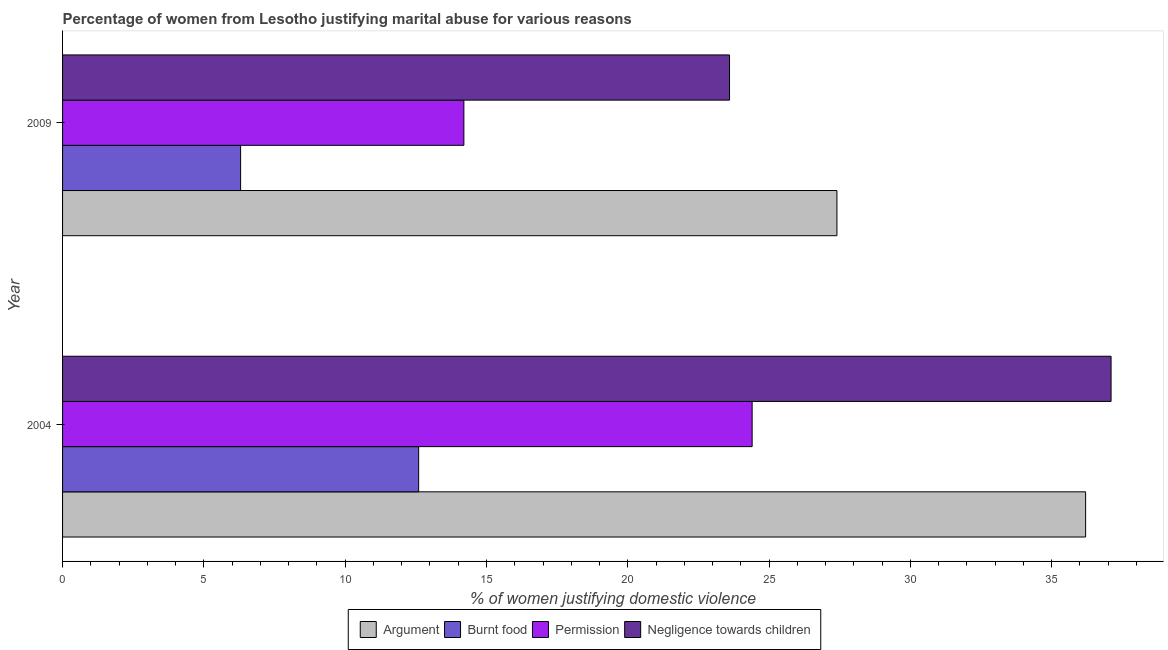How many groups of bars are there?
Your answer should be very brief. 2. What is the label of the 2nd group of bars from the top?
Offer a very short reply. 2004. What is the percentage of women justifying abuse for burning food in 2009?
Offer a terse response. 6.3. Across all years, what is the maximum percentage of women justifying abuse for burning food?
Ensure brevity in your answer.  12.6. Across all years, what is the minimum percentage of women justifying abuse for burning food?
Provide a succinct answer. 6.3. In which year was the percentage of women justifying abuse in the case of an argument minimum?
Make the answer very short. 2009. What is the total percentage of women justifying abuse in the case of an argument in the graph?
Make the answer very short. 63.6. What is the difference between the percentage of women justifying abuse for burning food in 2004 and that in 2009?
Make the answer very short. 6.3. What is the difference between the percentage of women justifying abuse for burning food in 2004 and the percentage of women justifying abuse in the case of an argument in 2009?
Your answer should be very brief. -14.8. What is the average percentage of women justifying abuse for showing negligence towards children per year?
Your response must be concise. 30.35. In the year 2004, what is the difference between the percentage of women justifying abuse for burning food and percentage of women justifying abuse for showing negligence towards children?
Your response must be concise. -24.5. In how many years, is the percentage of women justifying abuse for showing negligence towards children greater than 24 %?
Give a very brief answer. 1. What is the ratio of the percentage of women justifying abuse for going without permission in 2004 to that in 2009?
Offer a very short reply. 1.72. Is the percentage of women justifying abuse for burning food in 2004 less than that in 2009?
Make the answer very short. No. Is the difference between the percentage of women justifying abuse for showing negligence towards children in 2004 and 2009 greater than the difference between the percentage of women justifying abuse for going without permission in 2004 and 2009?
Offer a very short reply. Yes. In how many years, is the percentage of women justifying abuse for going without permission greater than the average percentage of women justifying abuse for going without permission taken over all years?
Your answer should be compact. 1. Is it the case that in every year, the sum of the percentage of women justifying abuse for showing negligence towards children and percentage of women justifying abuse for going without permission is greater than the sum of percentage of women justifying abuse in the case of an argument and percentage of women justifying abuse for burning food?
Give a very brief answer. No. What does the 2nd bar from the top in 2004 represents?
Your answer should be very brief. Permission. What does the 1st bar from the bottom in 2009 represents?
Offer a terse response. Argument. Is it the case that in every year, the sum of the percentage of women justifying abuse in the case of an argument and percentage of women justifying abuse for burning food is greater than the percentage of women justifying abuse for going without permission?
Offer a very short reply. Yes. Are all the bars in the graph horizontal?
Provide a succinct answer. Yes. What is the difference between two consecutive major ticks on the X-axis?
Your answer should be compact. 5. Does the graph contain any zero values?
Provide a succinct answer. No. Where does the legend appear in the graph?
Keep it short and to the point. Bottom center. How many legend labels are there?
Provide a short and direct response. 4. What is the title of the graph?
Provide a short and direct response. Percentage of women from Lesotho justifying marital abuse for various reasons. What is the label or title of the X-axis?
Your answer should be very brief. % of women justifying domestic violence. What is the label or title of the Y-axis?
Provide a succinct answer. Year. What is the % of women justifying domestic violence of Argument in 2004?
Provide a succinct answer. 36.2. What is the % of women justifying domestic violence of Burnt food in 2004?
Your answer should be very brief. 12.6. What is the % of women justifying domestic violence of Permission in 2004?
Your answer should be very brief. 24.4. What is the % of women justifying domestic violence of Negligence towards children in 2004?
Your answer should be very brief. 37.1. What is the % of women justifying domestic violence in Argument in 2009?
Offer a terse response. 27.4. What is the % of women justifying domestic violence of Negligence towards children in 2009?
Provide a succinct answer. 23.6. Across all years, what is the maximum % of women justifying domestic violence in Argument?
Your answer should be very brief. 36.2. Across all years, what is the maximum % of women justifying domestic violence of Permission?
Provide a short and direct response. 24.4. Across all years, what is the maximum % of women justifying domestic violence of Negligence towards children?
Offer a terse response. 37.1. Across all years, what is the minimum % of women justifying domestic violence in Argument?
Provide a succinct answer. 27.4. Across all years, what is the minimum % of women justifying domestic violence in Burnt food?
Give a very brief answer. 6.3. Across all years, what is the minimum % of women justifying domestic violence of Negligence towards children?
Your answer should be very brief. 23.6. What is the total % of women justifying domestic violence in Argument in the graph?
Give a very brief answer. 63.6. What is the total % of women justifying domestic violence of Burnt food in the graph?
Provide a succinct answer. 18.9. What is the total % of women justifying domestic violence in Permission in the graph?
Give a very brief answer. 38.6. What is the total % of women justifying domestic violence in Negligence towards children in the graph?
Ensure brevity in your answer.  60.7. What is the difference between the % of women justifying domestic violence in Argument in 2004 and that in 2009?
Keep it short and to the point. 8.8. What is the difference between the % of women justifying domestic violence of Permission in 2004 and that in 2009?
Offer a terse response. 10.2. What is the difference between the % of women justifying domestic violence in Argument in 2004 and the % of women justifying domestic violence in Burnt food in 2009?
Your response must be concise. 29.9. What is the difference between the % of women justifying domestic violence in Burnt food in 2004 and the % of women justifying domestic violence in Permission in 2009?
Ensure brevity in your answer.  -1.6. What is the difference between the % of women justifying domestic violence in Permission in 2004 and the % of women justifying domestic violence in Negligence towards children in 2009?
Make the answer very short. 0.8. What is the average % of women justifying domestic violence of Argument per year?
Your response must be concise. 31.8. What is the average % of women justifying domestic violence of Burnt food per year?
Keep it short and to the point. 9.45. What is the average % of women justifying domestic violence in Permission per year?
Your answer should be very brief. 19.3. What is the average % of women justifying domestic violence in Negligence towards children per year?
Ensure brevity in your answer.  30.35. In the year 2004, what is the difference between the % of women justifying domestic violence in Argument and % of women justifying domestic violence in Burnt food?
Offer a very short reply. 23.6. In the year 2004, what is the difference between the % of women justifying domestic violence in Argument and % of women justifying domestic violence in Permission?
Keep it short and to the point. 11.8. In the year 2004, what is the difference between the % of women justifying domestic violence of Argument and % of women justifying domestic violence of Negligence towards children?
Keep it short and to the point. -0.9. In the year 2004, what is the difference between the % of women justifying domestic violence of Burnt food and % of women justifying domestic violence of Negligence towards children?
Provide a short and direct response. -24.5. In the year 2009, what is the difference between the % of women justifying domestic violence of Argument and % of women justifying domestic violence of Burnt food?
Give a very brief answer. 21.1. In the year 2009, what is the difference between the % of women justifying domestic violence in Argument and % of women justifying domestic violence in Permission?
Your response must be concise. 13.2. In the year 2009, what is the difference between the % of women justifying domestic violence in Burnt food and % of women justifying domestic violence in Negligence towards children?
Your response must be concise. -17.3. In the year 2009, what is the difference between the % of women justifying domestic violence of Permission and % of women justifying domestic violence of Negligence towards children?
Offer a terse response. -9.4. What is the ratio of the % of women justifying domestic violence of Argument in 2004 to that in 2009?
Your answer should be very brief. 1.32. What is the ratio of the % of women justifying domestic violence in Burnt food in 2004 to that in 2009?
Provide a succinct answer. 2. What is the ratio of the % of women justifying domestic violence of Permission in 2004 to that in 2009?
Provide a short and direct response. 1.72. What is the ratio of the % of women justifying domestic violence of Negligence towards children in 2004 to that in 2009?
Provide a short and direct response. 1.57. What is the difference between the highest and the second highest % of women justifying domestic violence in Burnt food?
Your answer should be compact. 6.3. What is the difference between the highest and the second highest % of women justifying domestic violence in Permission?
Your answer should be very brief. 10.2. What is the difference between the highest and the second highest % of women justifying domestic violence in Negligence towards children?
Your response must be concise. 13.5. What is the difference between the highest and the lowest % of women justifying domestic violence of Negligence towards children?
Make the answer very short. 13.5. 